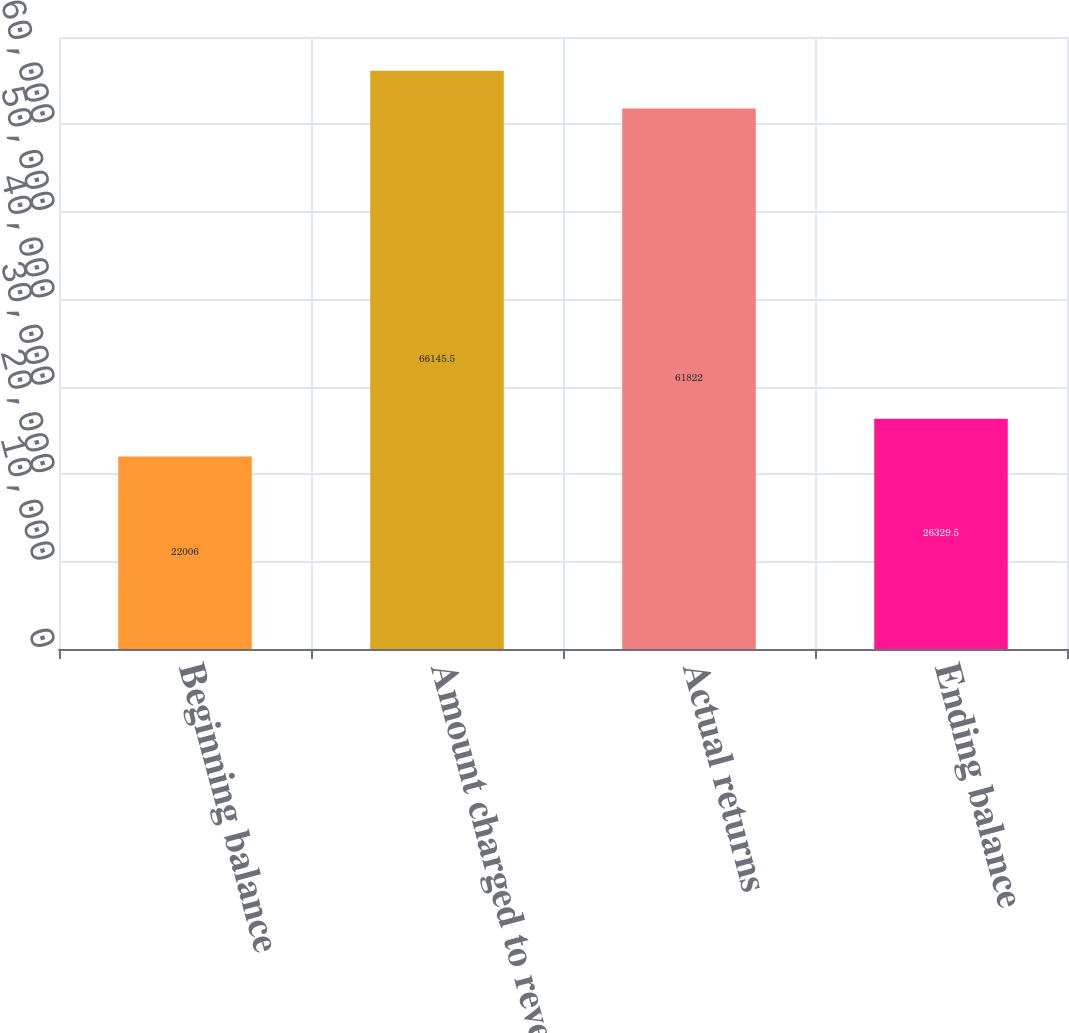<chart> <loc_0><loc_0><loc_500><loc_500><bar_chart><fcel>Beginning balance<fcel>Amount charged to revenue<fcel>Actual returns<fcel>Ending balance<nl><fcel>22006<fcel>66145.5<fcel>61822<fcel>26329.5<nl></chart> 